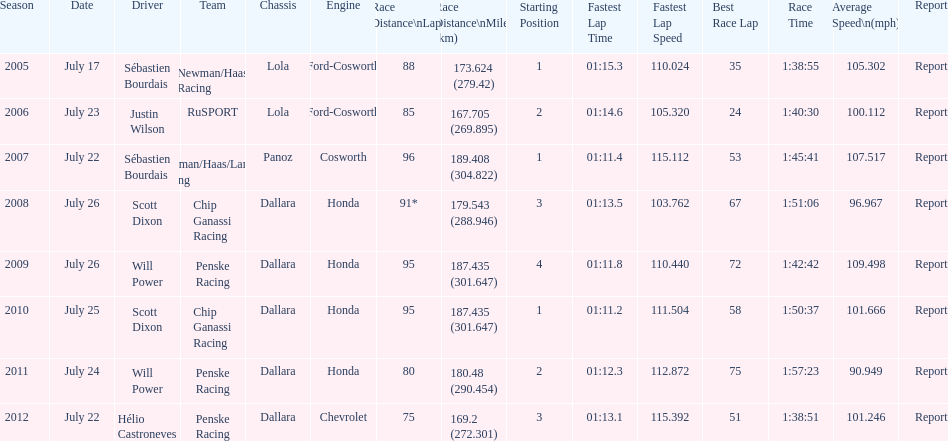What is the total number dallara chassis listed in the table? 5. 